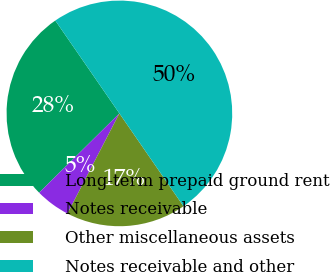<chart> <loc_0><loc_0><loc_500><loc_500><pie_chart><fcel>Long-term prepaid ground rent<fcel>Notes receivable<fcel>Other miscellaneous assets<fcel>Notes receivable and other<nl><fcel>27.79%<fcel>4.98%<fcel>17.23%<fcel>50.0%<nl></chart> 